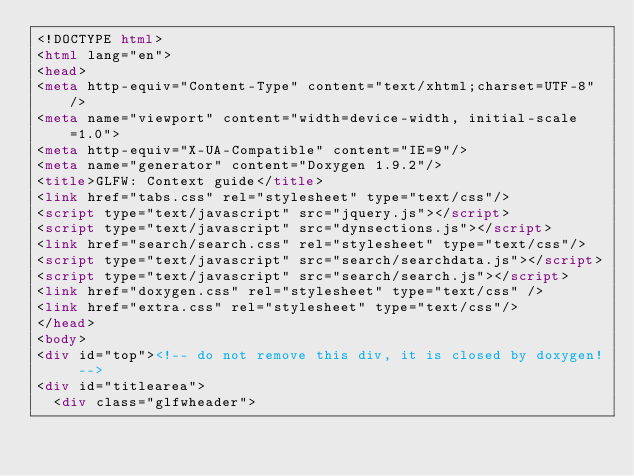<code> <loc_0><loc_0><loc_500><loc_500><_HTML_><!DOCTYPE html>
<html lang="en">
<head>
<meta http-equiv="Content-Type" content="text/xhtml;charset=UTF-8"/>
<meta name="viewport" content="width=device-width, initial-scale=1.0">
<meta http-equiv="X-UA-Compatible" content="IE=9"/>
<meta name="generator" content="Doxygen 1.9.2"/>
<title>GLFW: Context guide</title>
<link href="tabs.css" rel="stylesheet" type="text/css"/>
<script type="text/javascript" src="jquery.js"></script>
<script type="text/javascript" src="dynsections.js"></script>
<link href="search/search.css" rel="stylesheet" type="text/css"/>
<script type="text/javascript" src="search/searchdata.js"></script>
<script type="text/javascript" src="search/search.js"></script>
<link href="doxygen.css" rel="stylesheet" type="text/css" />
<link href="extra.css" rel="stylesheet" type="text/css"/>
</head>
<body>
<div id="top"><!-- do not remove this div, it is closed by doxygen! -->
<div id="titlearea">
	<div class="glfwheader"></code> 